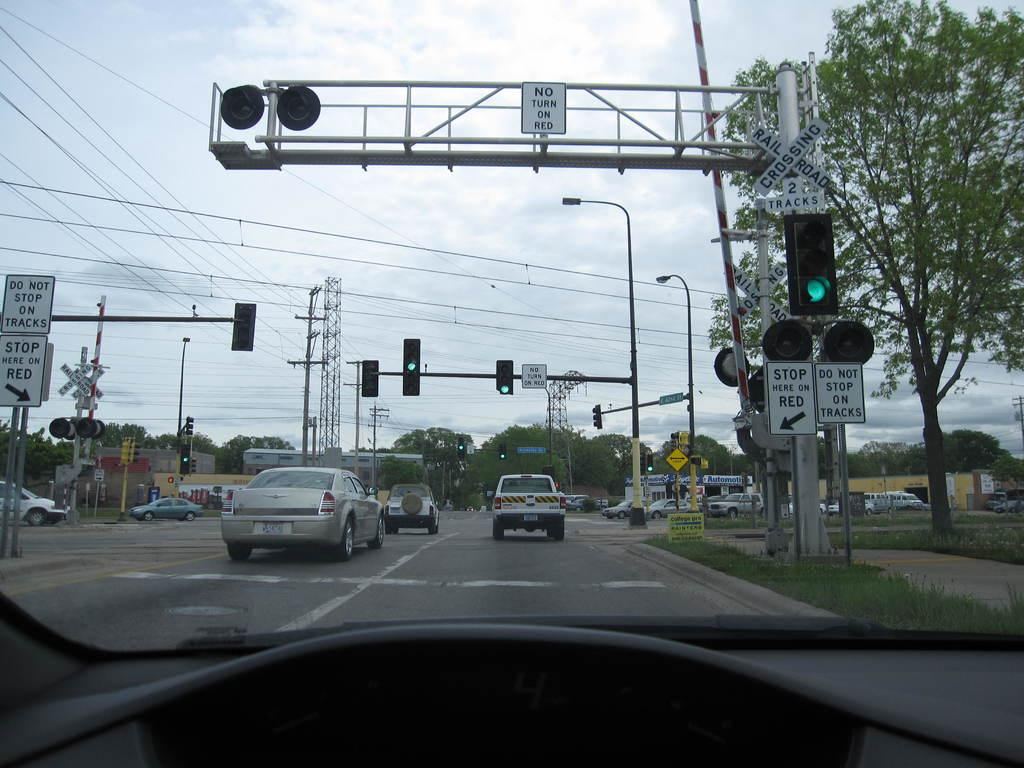<image>
Summarize the visual content of the image. a sign that says to stop here on red outside 